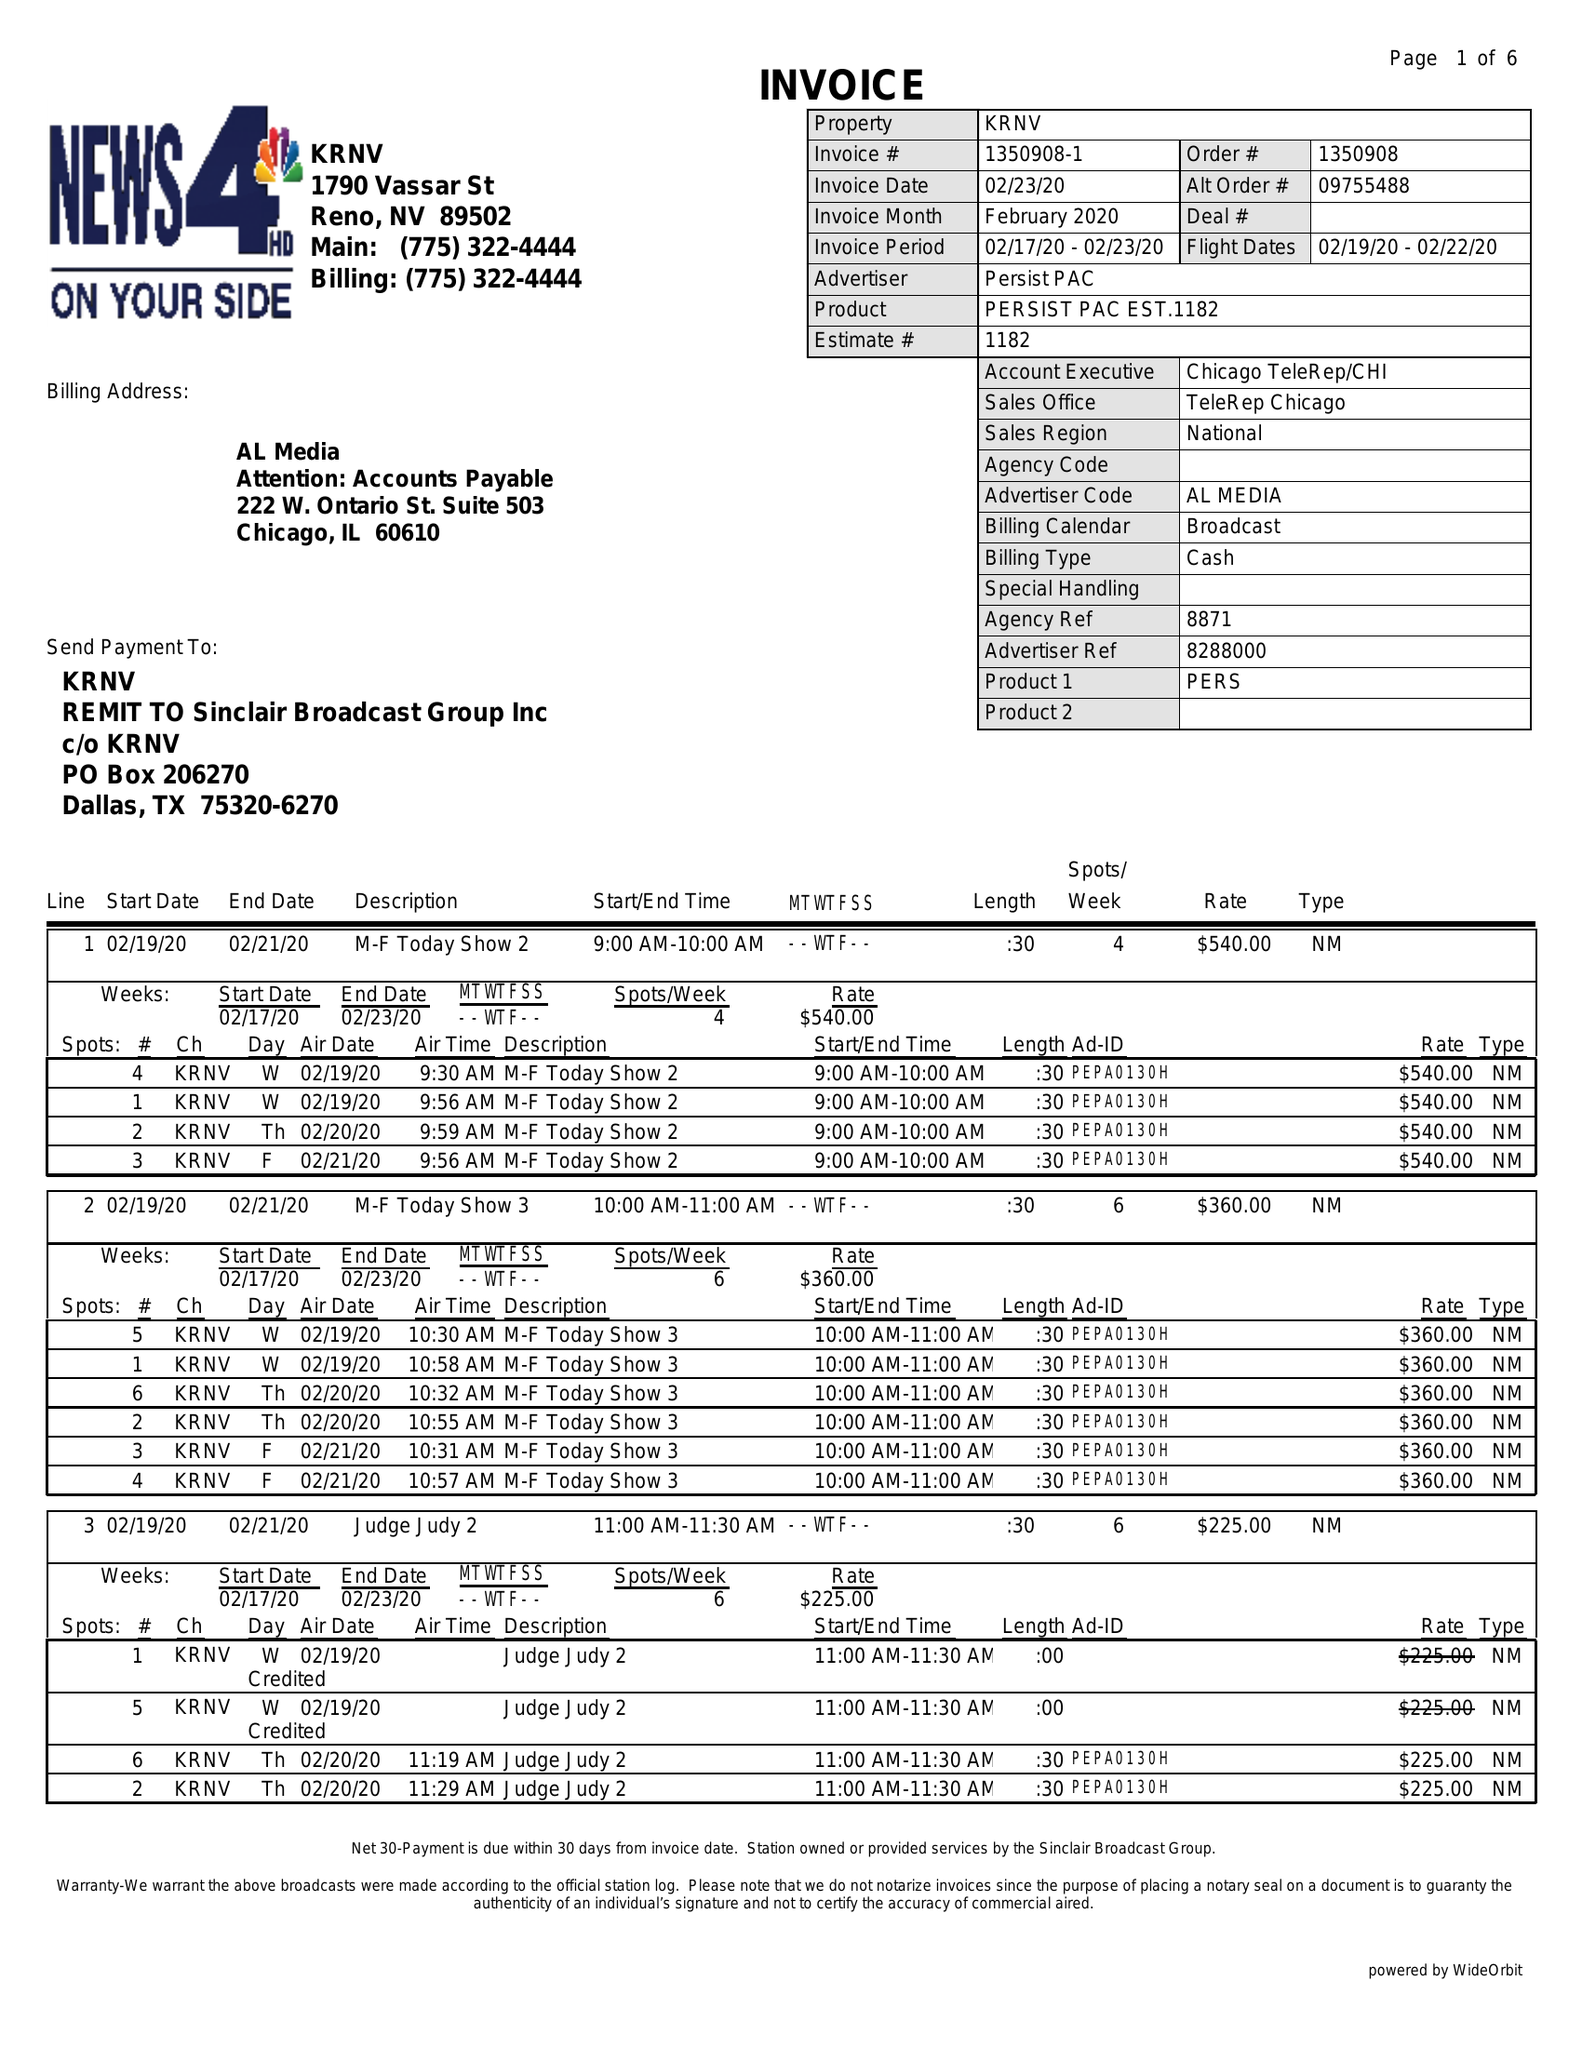What is the value for the flight_from?
Answer the question using a single word or phrase. 02/19/20 